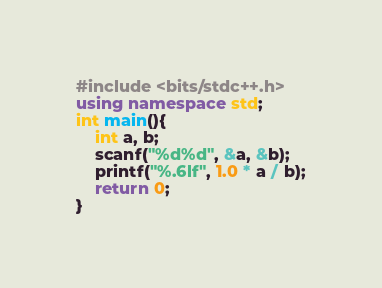Convert code to text. <code><loc_0><loc_0><loc_500><loc_500><_C++_>#include <bits/stdc++.h>
using namespace std;
int main(){
	int a, b;
	scanf("%d%d", &a, &b);
	printf("%.6lf", 1.0 * a / b);
	return 0;
}
</code> 